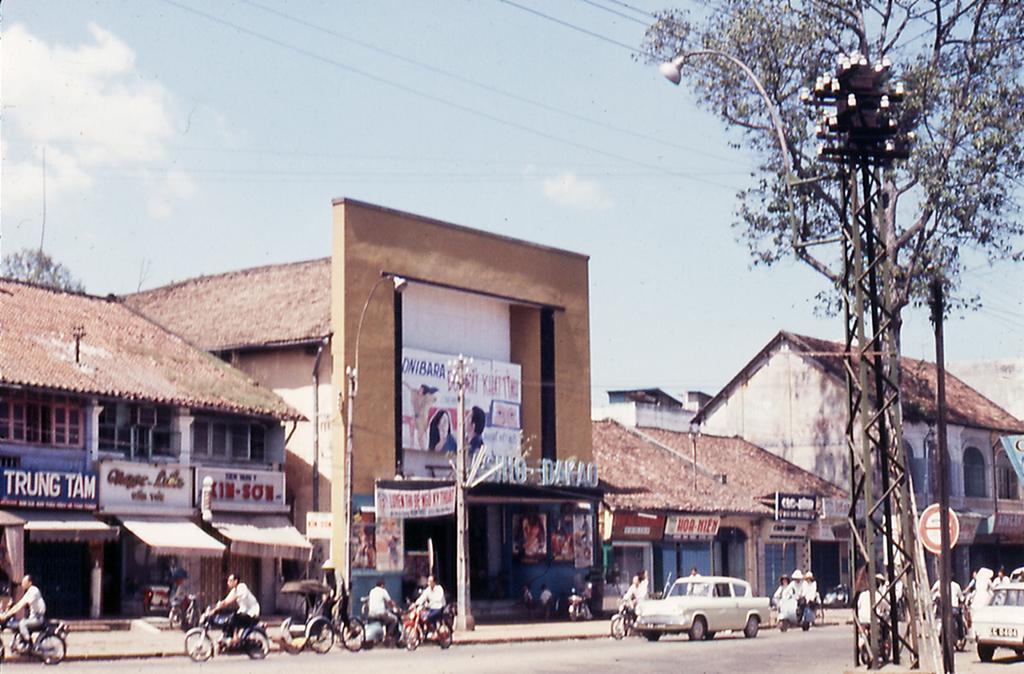Could you give a brief overview of what you see in this image? This picture is clicked outside the city. In this picture, we see many people riding bikes and there are cars moving on the road. On the right side, we see a tower, a street lights and a tree. There are many buildings with a brown color roof. We see street lights and hoarding boards in white color with some text written on it. At the top of the picture, we see the sky and the wires. 